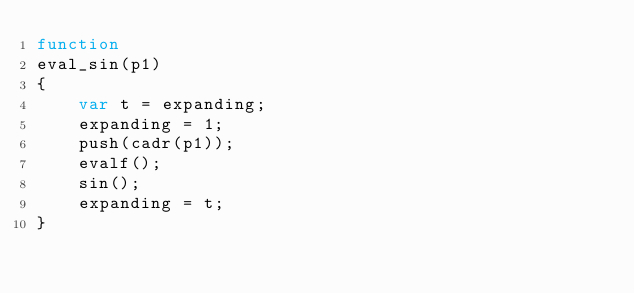<code> <loc_0><loc_0><loc_500><loc_500><_JavaScript_>function
eval_sin(p1)
{
	var t = expanding;
	expanding = 1;
	push(cadr(p1));
	evalf();
	sin();
	expanding = t;
}
</code> 